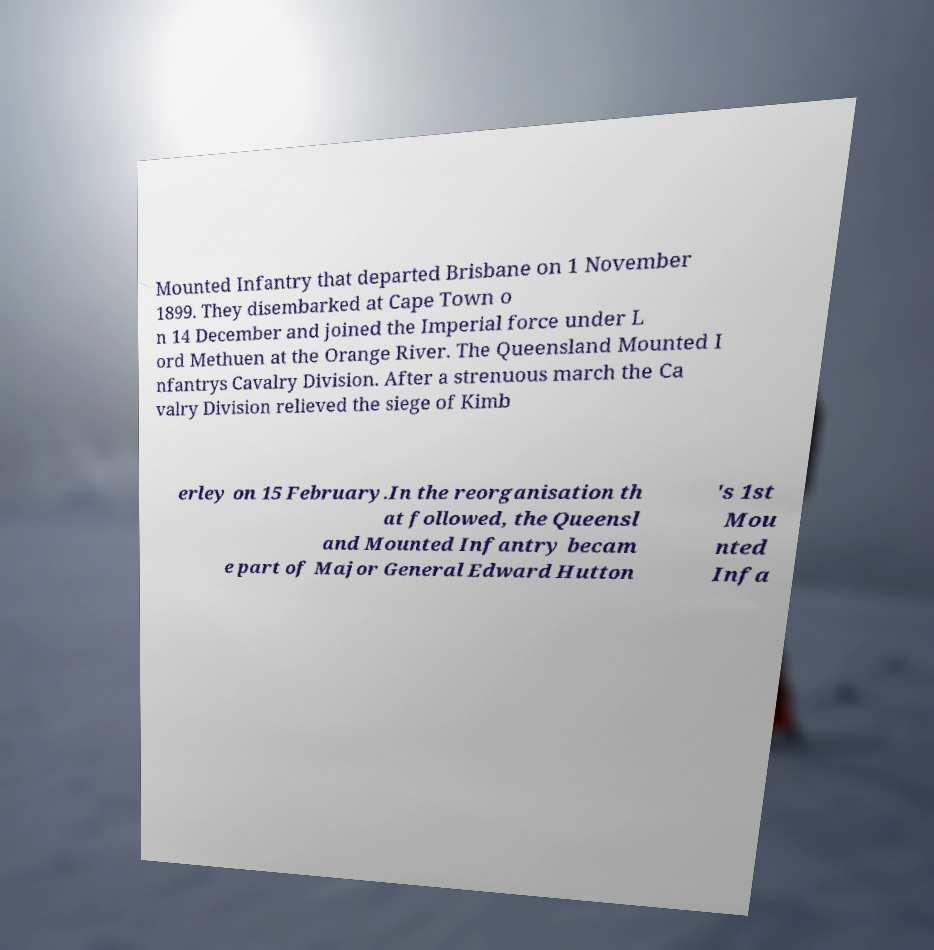There's text embedded in this image that I need extracted. Can you transcribe it verbatim? Mounted Infantry that departed Brisbane on 1 November 1899. They disembarked at Cape Town o n 14 December and joined the Imperial force under L ord Methuen at the Orange River. The Queensland Mounted I nfantrys Cavalry Division. After a strenuous march the Ca valry Division relieved the siege of Kimb erley on 15 February.In the reorganisation th at followed, the Queensl and Mounted Infantry becam e part of Major General Edward Hutton 's 1st Mou nted Infa 